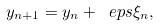Convert formula to latex. <formula><loc_0><loc_0><loc_500><loc_500>y _ { n + 1 } = y _ { n } + \ e p s \xi _ { n } ,</formula> 